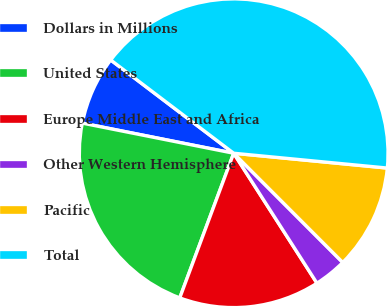Convert chart to OTSL. <chart><loc_0><loc_0><loc_500><loc_500><pie_chart><fcel>Dollars in Millions<fcel>United States<fcel>Europe Middle East and Africa<fcel>Other Western Hemisphere<fcel>Pacific<fcel>Total<nl><fcel>7.2%<fcel>22.45%<fcel>14.75%<fcel>3.42%<fcel>10.98%<fcel>41.21%<nl></chart> 